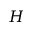Convert formula to latex. <formula><loc_0><loc_0><loc_500><loc_500>H</formula> 